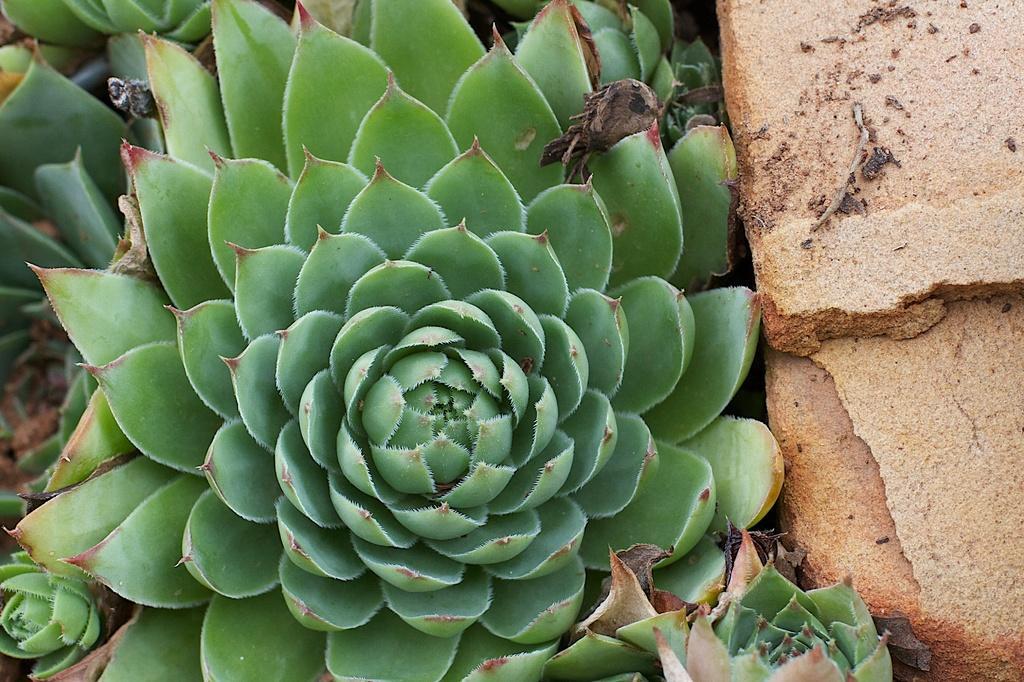In one or two sentences, can you explain what this image depicts? There are plants. On the right side there are stones. 